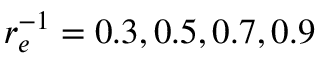<formula> <loc_0><loc_0><loc_500><loc_500>r _ { e } ^ { - 1 } = 0 . 3 , 0 . 5 , 0 . 7 , 0 . 9</formula> 